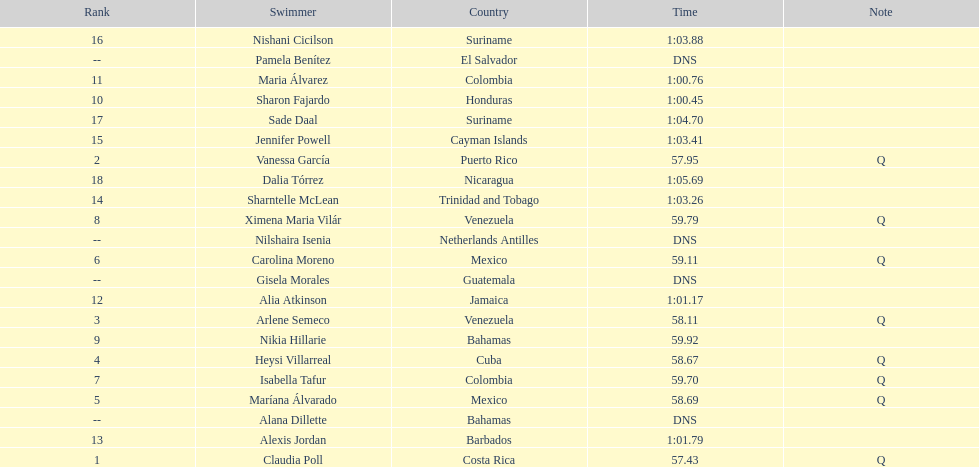What swimmer had the top or first rank? Claudia Poll. 